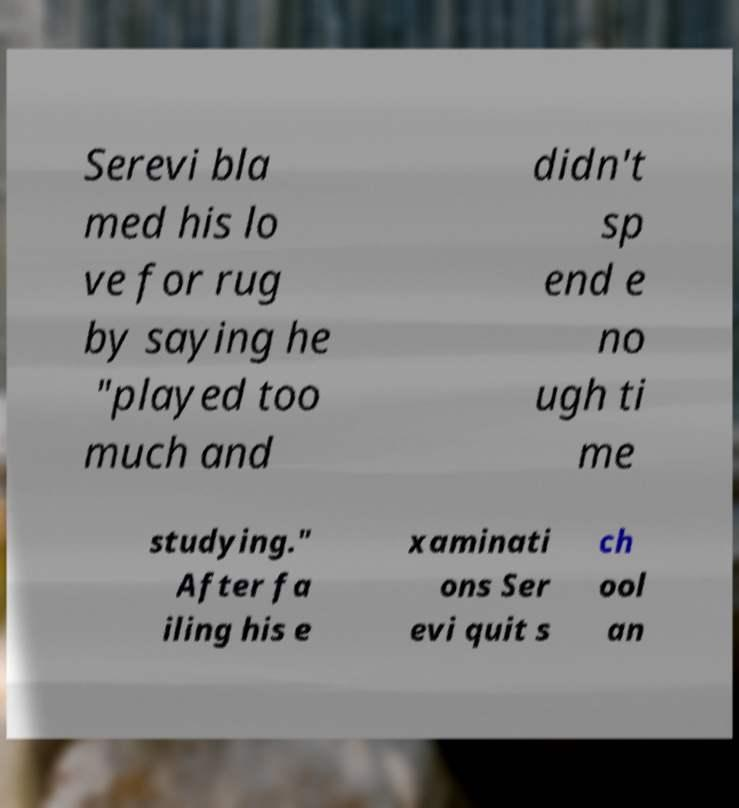For documentation purposes, I need the text within this image transcribed. Could you provide that? Serevi bla med his lo ve for rug by saying he "played too much and didn't sp end e no ugh ti me studying." After fa iling his e xaminati ons Ser evi quit s ch ool an 